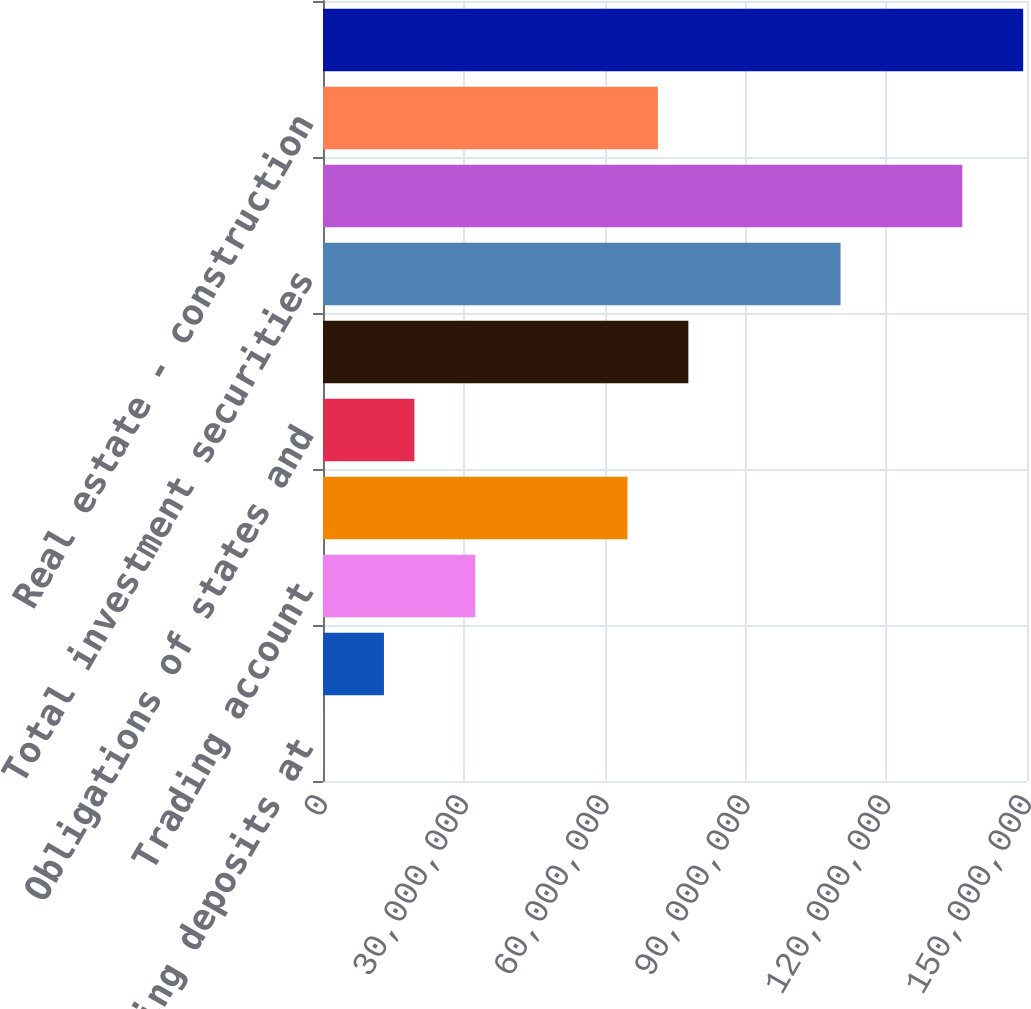<chart> <loc_0><loc_0><loc_500><loc_500><bar_chart><fcel>Interest-bearing deposits at<fcel>Federal funds sold<fcel>Trading account<fcel>US Treasury and federal<fcel>Obligations of states and<fcel>Other<fcel>Total investment securities<fcel>Commercial financial leasing<fcel>Real estate - construction<fcel>Real estate - mortgage<nl><fcel>18431<fcel>1.29899e+07<fcel>3.2447e+07<fcel>6.48756e+07<fcel>1.94756e+07<fcel>7.78471e+07<fcel>1.10276e+08<fcel>1.36219e+08<fcel>7.13614e+07<fcel>1.4919e+08<nl></chart> 